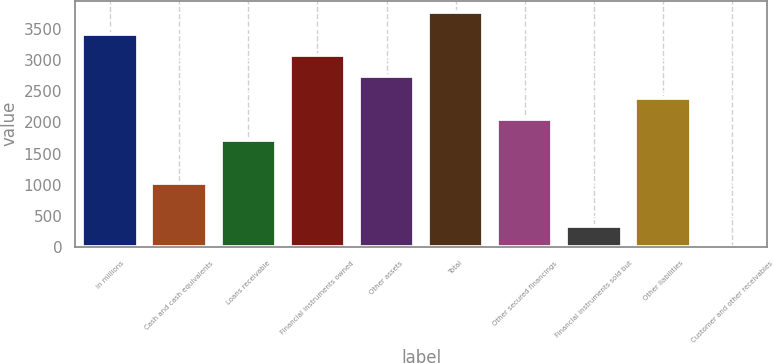Convert chart. <chart><loc_0><loc_0><loc_500><loc_500><bar_chart><fcel>in millions<fcel>Cash and cash equivalents<fcel>Loans receivable<fcel>Financial instruments owned<fcel>Other assets<fcel>Total<fcel>Other secured financings<fcel>Financial instruments sold but<fcel>Other liabilities<fcel>Customer and other receivables<nl><fcel>3426<fcel>1029.2<fcel>1714<fcel>3083.6<fcel>2741.2<fcel>3768.4<fcel>2056.4<fcel>344.4<fcel>2398.8<fcel>2<nl></chart> 